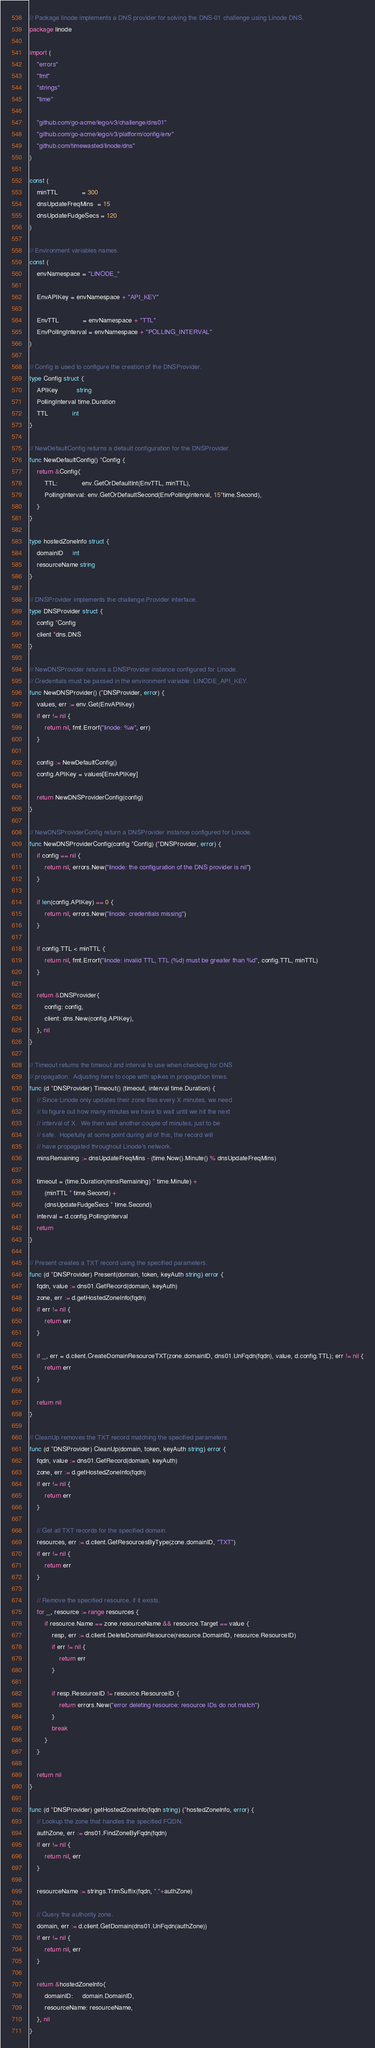<code> <loc_0><loc_0><loc_500><loc_500><_Go_>// Package linode implements a DNS provider for solving the DNS-01 challenge using Linode DNS.
package linode

import (
	"errors"
	"fmt"
	"strings"
	"time"

	"github.com/go-acme/lego/v3/challenge/dns01"
	"github.com/go-acme/lego/v3/platform/config/env"
	"github.com/timewasted/linode/dns"
)

const (
	minTTL             = 300
	dnsUpdateFreqMins  = 15
	dnsUpdateFudgeSecs = 120
)

// Environment variables names.
const (
	envNamespace = "LINODE_"

	EnvAPIKey = envNamespace + "API_KEY"

	EnvTTL             = envNamespace + "TTL"
	EnvPollingInterval = envNamespace + "POLLING_INTERVAL"
)

// Config is used to configure the creation of the DNSProvider.
type Config struct {
	APIKey          string
	PollingInterval time.Duration
	TTL             int
}

// NewDefaultConfig returns a default configuration for the DNSProvider.
func NewDefaultConfig() *Config {
	return &Config{
		TTL:             env.GetOrDefaultInt(EnvTTL, minTTL),
		PollingInterval: env.GetOrDefaultSecond(EnvPollingInterval, 15*time.Second),
	}
}

type hostedZoneInfo struct {
	domainID     int
	resourceName string
}

// DNSProvider implements the challenge.Provider interface.
type DNSProvider struct {
	config *Config
	client *dns.DNS
}

// NewDNSProvider returns a DNSProvider instance configured for Linode.
// Credentials must be passed in the environment variable: LINODE_API_KEY.
func NewDNSProvider() (*DNSProvider, error) {
	values, err := env.Get(EnvAPIKey)
	if err != nil {
		return nil, fmt.Errorf("linode: %w", err)
	}

	config := NewDefaultConfig()
	config.APIKey = values[EnvAPIKey]

	return NewDNSProviderConfig(config)
}

// NewDNSProviderConfig return a DNSProvider instance configured for Linode.
func NewDNSProviderConfig(config *Config) (*DNSProvider, error) {
	if config == nil {
		return nil, errors.New("linode: the configuration of the DNS provider is nil")
	}

	if len(config.APIKey) == 0 {
		return nil, errors.New("linode: credentials missing")
	}

	if config.TTL < minTTL {
		return nil, fmt.Errorf("linode: invalid TTL, TTL (%d) must be greater than %d", config.TTL, minTTL)
	}

	return &DNSProvider{
		config: config,
		client: dns.New(config.APIKey),
	}, nil
}

// Timeout returns the timeout and interval to use when checking for DNS
// propagation.  Adjusting here to cope with spikes in propagation times.
func (d *DNSProvider) Timeout() (timeout, interval time.Duration) {
	// Since Linode only updates their zone files every X minutes, we need
	// to figure out how many minutes we have to wait until we hit the next
	// interval of X.  We then wait another couple of minutes, just to be
	// safe.  Hopefully at some point during all of this, the record will
	// have propagated throughout Linode's network.
	minsRemaining := dnsUpdateFreqMins - (time.Now().Minute() % dnsUpdateFreqMins)

	timeout = (time.Duration(minsRemaining) * time.Minute) +
		(minTTL * time.Second) +
		(dnsUpdateFudgeSecs * time.Second)
	interval = d.config.PollingInterval
	return
}

// Present creates a TXT record using the specified parameters.
func (d *DNSProvider) Present(domain, token, keyAuth string) error {
	fqdn, value := dns01.GetRecord(domain, keyAuth)
	zone, err := d.getHostedZoneInfo(fqdn)
	if err != nil {
		return err
	}

	if _, err = d.client.CreateDomainResourceTXT(zone.domainID, dns01.UnFqdn(fqdn), value, d.config.TTL); err != nil {
		return err
	}

	return nil
}

// CleanUp removes the TXT record matching the specified parameters.
func (d *DNSProvider) CleanUp(domain, token, keyAuth string) error {
	fqdn, value := dns01.GetRecord(domain, keyAuth)
	zone, err := d.getHostedZoneInfo(fqdn)
	if err != nil {
		return err
	}

	// Get all TXT records for the specified domain.
	resources, err := d.client.GetResourcesByType(zone.domainID, "TXT")
	if err != nil {
		return err
	}

	// Remove the specified resource, if it exists.
	for _, resource := range resources {
		if resource.Name == zone.resourceName && resource.Target == value {
			resp, err := d.client.DeleteDomainResource(resource.DomainID, resource.ResourceID)
			if err != nil {
				return err
			}

			if resp.ResourceID != resource.ResourceID {
				return errors.New("error deleting resource: resource IDs do not match")
			}
			break
		}
	}

	return nil
}

func (d *DNSProvider) getHostedZoneInfo(fqdn string) (*hostedZoneInfo, error) {
	// Lookup the zone that handles the specified FQDN.
	authZone, err := dns01.FindZoneByFqdn(fqdn)
	if err != nil {
		return nil, err
	}

	resourceName := strings.TrimSuffix(fqdn, "."+authZone)

	// Query the authority zone.
	domain, err := d.client.GetDomain(dns01.UnFqdn(authZone))
	if err != nil {
		return nil, err
	}

	return &hostedZoneInfo{
		domainID:     domain.DomainID,
		resourceName: resourceName,
	}, nil
}
</code> 